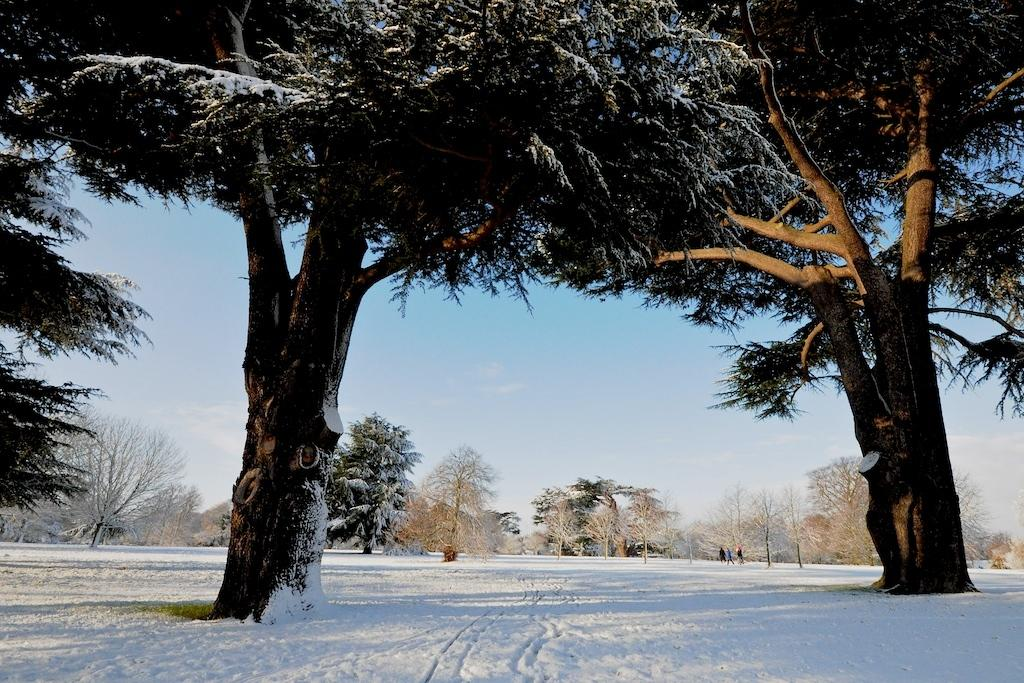What is the primary feature of the image? There are many trees in the image. Can you describe the people in the image? There are three persons in the background of the image. What can be seen in the sky? The sky is visible in the image. What is the ground covered with in the image? There is snow at the bottom of the image. What type of fire can be seen in the image? There is no fire present in the image. How many cats are visible in the image? There are no cats visible in the image. 